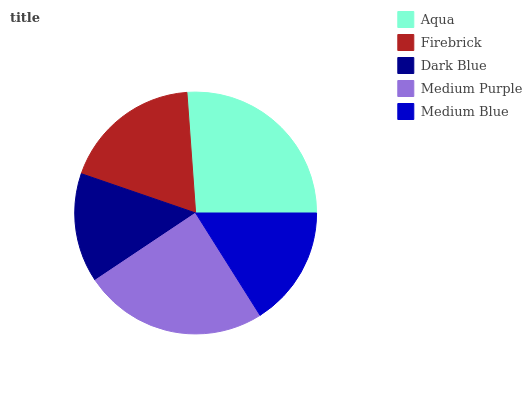Is Dark Blue the minimum?
Answer yes or no. Yes. Is Aqua the maximum?
Answer yes or no. Yes. Is Firebrick the minimum?
Answer yes or no. No. Is Firebrick the maximum?
Answer yes or no. No. Is Aqua greater than Firebrick?
Answer yes or no. Yes. Is Firebrick less than Aqua?
Answer yes or no. Yes. Is Firebrick greater than Aqua?
Answer yes or no. No. Is Aqua less than Firebrick?
Answer yes or no. No. Is Firebrick the high median?
Answer yes or no. Yes. Is Firebrick the low median?
Answer yes or no. Yes. Is Dark Blue the high median?
Answer yes or no. No. Is Aqua the low median?
Answer yes or no. No. 